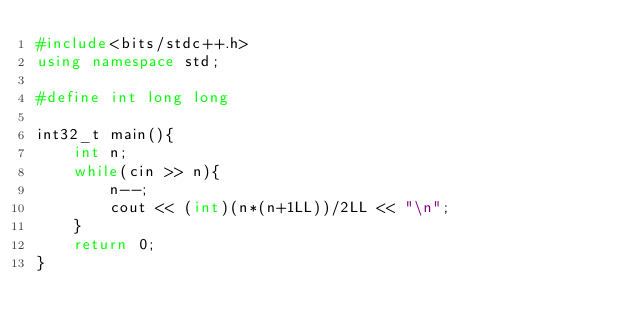Convert code to text. <code><loc_0><loc_0><loc_500><loc_500><_C++_>#include<bits/stdc++.h>
using namespace std;

#define int long long

int32_t main(){
    int n;
    while(cin >> n){
        n--;
        cout << (int)(n*(n+1LL))/2LL << "\n";
    }
    return 0;
}</code> 